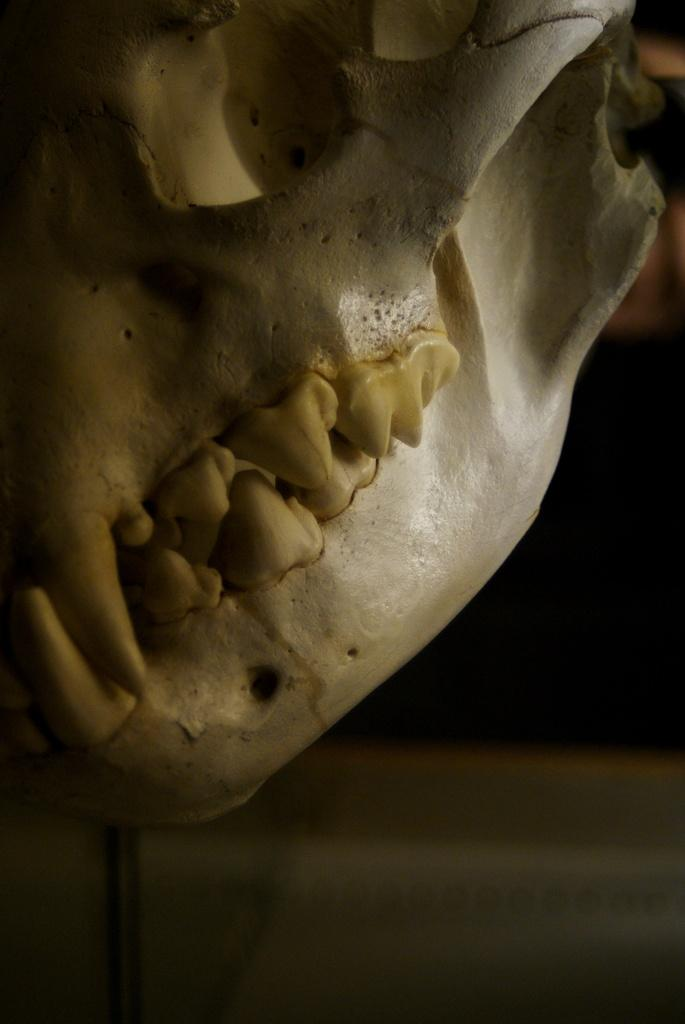What is the main subject of the image? The main subject of the image is a skull face of an animal. What color is the skull face? The skull face is white in color. How would you describe the overall appearance of the image? The image is dark overall. Are there any areas in the image that are lighter in color? Yes, there is a lighter area in the image, which is white. What type of print is visible on the zebra in the image? There is no zebra present in the image, and therefore no print can be observed. Can you hear any thunder in the image? The image is silent, and there is no indication of thunder or any sound. 